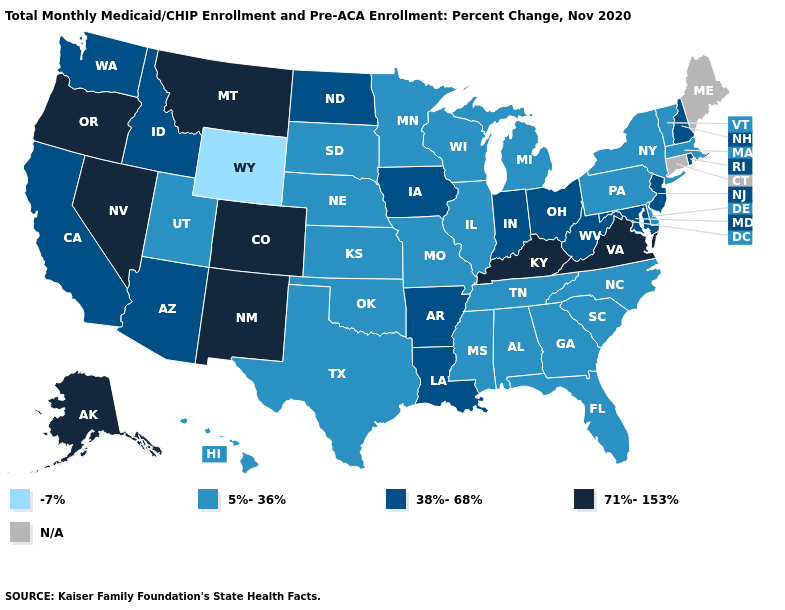What is the value of Colorado?
Short answer required. 71%-153%. What is the value of Nebraska?
Quick response, please. 5%-36%. What is the value of New York?
Keep it brief. 5%-36%. Name the states that have a value in the range -7%?
Write a very short answer. Wyoming. Does Nevada have the highest value in the West?
Write a very short answer. Yes. Name the states that have a value in the range -7%?
Concise answer only. Wyoming. Name the states that have a value in the range -7%?
Give a very brief answer. Wyoming. What is the value of Ohio?
Quick response, please. 38%-68%. Which states have the highest value in the USA?
Write a very short answer. Alaska, Colorado, Kentucky, Montana, Nevada, New Mexico, Oregon, Virginia. Name the states that have a value in the range 38%-68%?
Answer briefly. Arizona, Arkansas, California, Idaho, Indiana, Iowa, Louisiana, Maryland, New Hampshire, New Jersey, North Dakota, Ohio, Rhode Island, Washington, West Virginia. What is the value of Wyoming?
Short answer required. -7%. Name the states that have a value in the range 5%-36%?
Be succinct. Alabama, Delaware, Florida, Georgia, Hawaii, Illinois, Kansas, Massachusetts, Michigan, Minnesota, Mississippi, Missouri, Nebraska, New York, North Carolina, Oklahoma, Pennsylvania, South Carolina, South Dakota, Tennessee, Texas, Utah, Vermont, Wisconsin. Name the states that have a value in the range -7%?
Short answer required. Wyoming. What is the value of Vermont?
Be succinct. 5%-36%. Name the states that have a value in the range -7%?
Be succinct. Wyoming. 